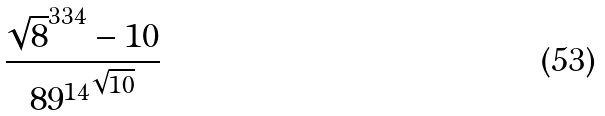Convert formula to latex. <formula><loc_0><loc_0><loc_500><loc_500>\frac { \sqrt { 8 } ^ { 3 3 4 } - 1 0 } { { 8 9 ^ { 1 4 } } ^ { \sqrt { 1 0 } } }</formula> 